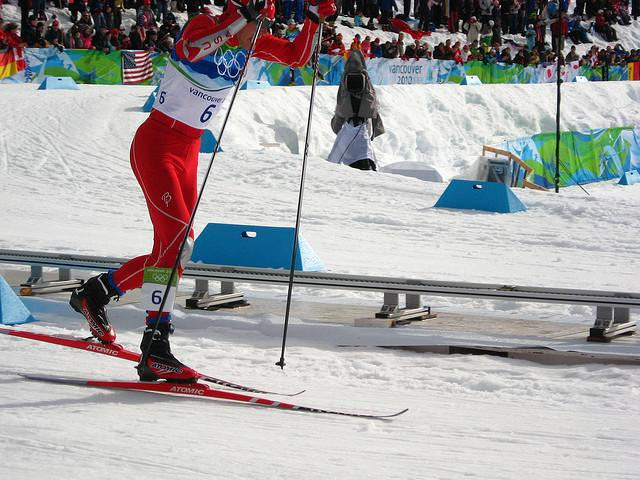What level of event is this? Please explain your reasoning. international. The names of countries are on the people's uniforms. 